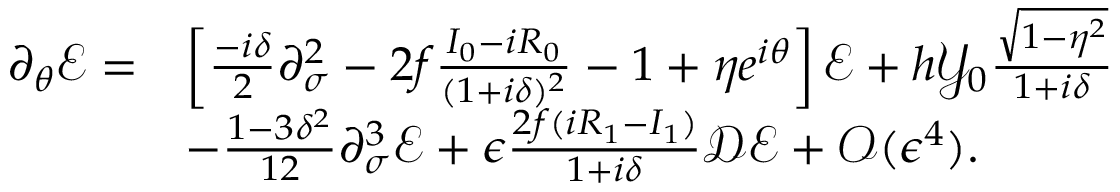<formula> <loc_0><loc_0><loc_500><loc_500>\begin{array} { r l } { \partial _ { \theta } \mathcal { E } = } & { \left [ \frac { - i \delta } { 2 } \partial _ { \sigma } ^ { 2 } - 2 f \frac { I _ { 0 } - i R _ { 0 } } { ( 1 + i \delta ) ^ { 2 } } - 1 + \eta e ^ { i \theta } \right ] \mathcal { E } + h \mathcal { Y } _ { 0 } \frac { \sqrt { 1 - \eta ^ { 2 } } } { 1 + i \delta } } \\ & { - \frac { 1 - 3 \delta ^ { 2 } } { 1 2 } \partial _ { \sigma } ^ { 3 } \mathcal { E } + \epsilon \frac { 2 f ( i R _ { 1 } - I _ { 1 } ) } { 1 + i \delta } \mathcal { D } \mathcal { E } + \mathcal { O } ( \epsilon ^ { 4 } ) . } \end{array}</formula> 